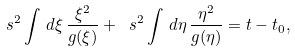Convert formula to latex. <formula><loc_0><loc_0><loc_500><loc_500>\ s ^ { 2 } \int \, d \xi \, \frac { \xi ^ { 2 } } { g ( \xi ) } + \ s ^ { 2 } \int \, d \eta \, \frac { \eta ^ { 2 } } { g ( \eta ) } = t - t _ { 0 } ,</formula> 